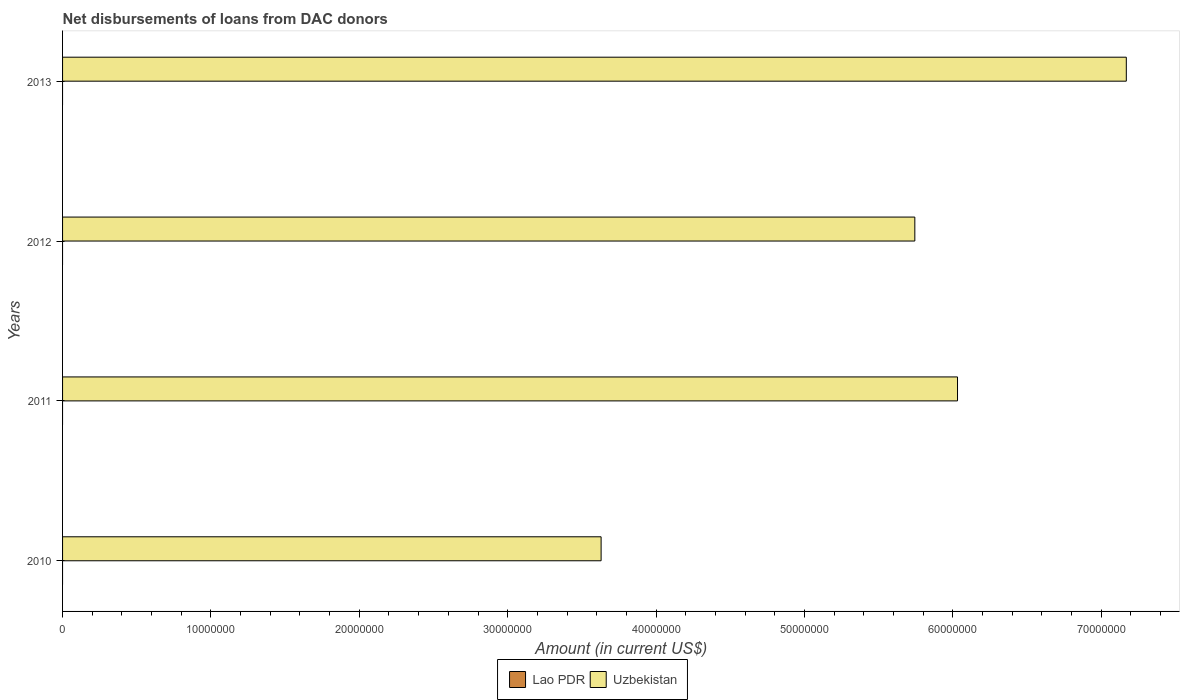How many different coloured bars are there?
Ensure brevity in your answer.  1. Are the number of bars per tick equal to the number of legend labels?
Provide a succinct answer. No. How many bars are there on the 4th tick from the bottom?
Make the answer very short. 1. What is the label of the 1st group of bars from the top?
Give a very brief answer. 2013. Across all years, what is the maximum amount of loans disbursed in Uzbekistan?
Your answer should be compact. 7.17e+07. Across all years, what is the minimum amount of loans disbursed in Lao PDR?
Provide a succinct answer. 0. What is the total amount of loans disbursed in Uzbekistan in the graph?
Provide a succinct answer. 2.26e+08. What is the difference between the amount of loans disbursed in Uzbekistan in 2010 and that in 2013?
Give a very brief answer. -3.54e+07. What is the difference between the amount of loans disbursed in Uzbekistan in 2011 and the amount of loans disbursed in Lao PDR in 2013?
Ensure brevity in your answer.  6.03e+07. What is the average amount of loans disbursed in Lao PDR per year?
Offer a terse response. 0. What is the ratio of the amount of loans disbursed in Uzbekistan in 2010 to that in 2011?
Offer a very short reply. 0.6. What is the difference between the highest and the second highest amount of loans disbursed in Uzbekistan?
Offer a very short reply. 1.14e+07. What is the difference between the highest and the lowest amount of loans disbursed in Uzbekistan?
Provide a short and direct response. 3.54e+07. In how many years, is the amount of loans disbursed in Lao PDR greater than the average amount of loans disbursed in Lao PDR taken over all years?
Your response must be concise. 0. Is the sum of the amount of loans disbursed in Uzbekistan in 2011 and 2013 greater than the maximum amount of loans disbursed in Lao PDR across all years?
Ensure brevity in your answer.  Yes. How many bars are there?
Provide a succinct answer. 4. Are all the bars in the graph horizontal?
Your answer should be very brief. Yes. What is the difference between two consecutive major ticks on the X-axis?
Ensure brevity in your answer.  1.00e+07. Does the graph contain grids?
Make the answer very short. No. What is the title of the graph?
Give a very brief answer. Net disbursements of loans from DAC donors. Does "India" appear as one of the legend labels in the graph?
Give a very brief answer. No. What is the Amount (in current US$) of Lao PDR in 2010?
Give a very brief answer. 0. What is the Amount (in current US$) in Uzbekistan in 2010?
Offer a very short reply. 3.63e+07. What is the Amount (in current US$) of Uzbekistan in 2011?
Offer a very short reply. 6.03e+07. What is the Amount (in current US$) of Lao PDR in 2012?
Your answer should be very brief. 0. What is the Amount (in current US$) in Uzbekistan in 2012?
Offer a very short reply. 5.74e+07. What is the Amount (in current US$) of Uzbekistan in 2013?
Your answer should be compact. 7.17e+07. Across all years, what is the maximum Amount (in current US$) of Uzbekistan?
Your response must be concise. 7.17e+07. Across all years, what is the minimum Amount (in current US$) of Uzbekistan?
Keep it short and to the point. 3.63e+07. What is the total Amount (in current US$) in Lao PDR in the graph?
Your response must be concise. 0. What is the total Amount (in current US$) in Uzbekistan in the graph?
Provide a succinct answer. 2.26e+08. What is the difference between the Amount (in current US$) of Uzbekistan in 2010 and that in 2011?
Your answer should be compact. -2.40e+07. What is the difference between the Amount (in current US$) of Uzbekistan in 2010 and that in 2012?
Your response must be concise. -2.11e+07. What is the difference between the Amount (in current US$) of Uzbekistan in 2010 and that in 2013?
Provide a short and direct response. -3.54e+07. What is the difference between the Amount (in current US$) of Uzbekistan in 2011 and that in 2012?
Provide a short and direct response. 2.88e+06. What is the difference between the Amount (in current US$) in Uzbekistan in 2011 and that in 2013?
Your answer should be very brief. -1.14e+07. What is the difference between the Amount (in current US$) of Uzbekistan in 2012 and that in 2013?
Ensure brevity in your answer.  -1.43e+07. What is the average Amount (in current US$) in Lao PDR per year?
Provide a succinct answer. 0. What is the average Amount (in current US$) of Uzbekistan per year?
Offer a terse response. 5.64e+07. What is the ratio of the Amount (in current US$) in Uzbekistan in 2010 to that in 2011?
Offer a very short reply. 0.6. What is the ratio of the Amount (in current US$) in Uzbekistan in 2010 to that in 2012?
Offer a very short reply. 0.63. What is the ratio of the Amount (in current US$) of Uzbekistan in 2010 to that in 2013?
Give a very brief answer. 0.51. What is the ratio of the Amount (in current US$) of Uzbekistan in 2011 to that in 2012?
Provide a short and direct response. 1.05. What is the ratio of the Amount (in current US$) of Uzbekistan in 2011 to that in 2013?
Provide a succinct answer. 0.84. What is the ratio of the Amount (in current US$) in Uzbekistan in 2012 to that in 2013?
Your response must be concise. 0.8. What is the difference between the highest and the second highest Amount (in current US$) in Uzbekistan?
Offer a terse response. 1.14e+07. What is the difference between the highest and the lowest Amount (in current US$) of Uzbekistan?
Make the answer very short. 3.54e+07. 